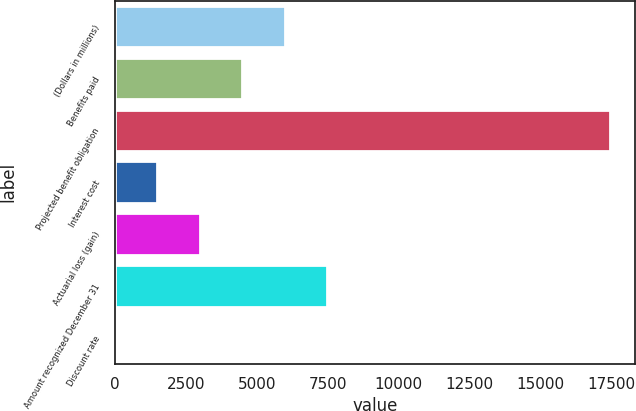Convert chart to OTSL. <chart><loc_0><loc_0><loc_500><loc_500><bar_chart><fcel>(Dollars in millions)<fcel>Benefits paid<fcel>Projected benefit obligation<fcel>Interest cost<fcel>Actuarial loss (gain)<fcel>Amount recognized December 31<fcel>Discount rate<nl><fcel>5995.28<fcel>4497.5<fcel>17456.6<fcel>1501.94<fcel>2999.72<fcel>7493.06<fcel>4.16<nl></chart> 